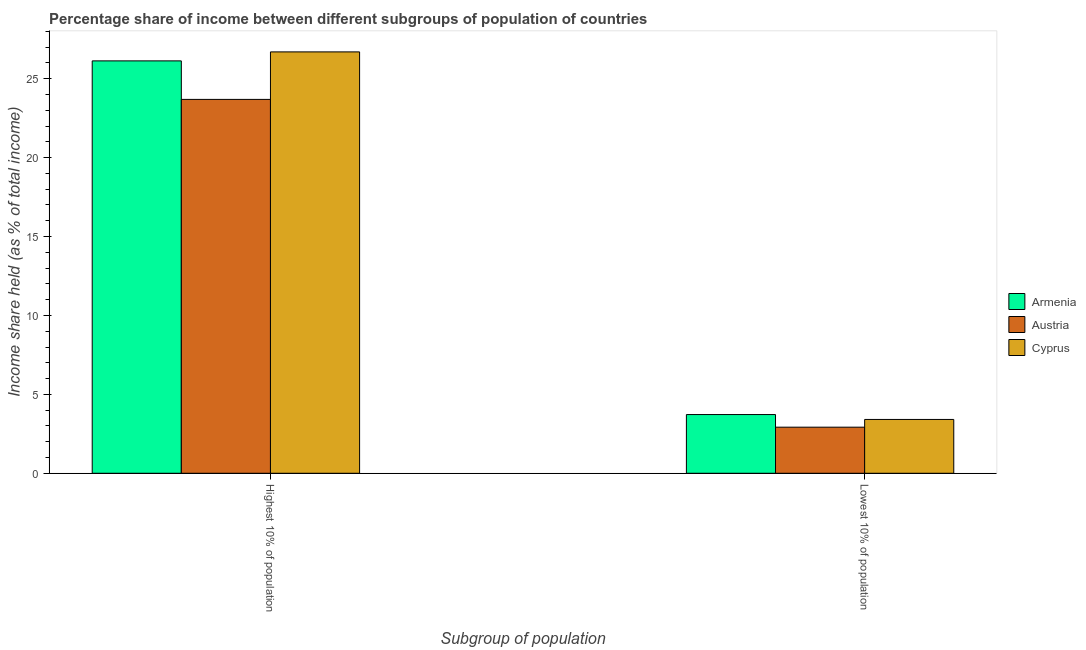How many different coloured bars are there?
Offer a terse response. 3. How many groups of bars are there?
Ensure brevity in your answer.  2. Are the number of bars on each tick of the X-axis equal?
Your response must be concise. Yes. How many bars are there on the 1st tick from the left?
Keep it short and to the point. 3. How many bars are there on the 2nd tick from the right?
Your answer should be very brief. 3. What is the label of the 1st group of bars from the left?
Provide a short and direct response. Highest 10% of population. What is the income share held by lowest 10% of the population in Cyprus?
Ensure brevity in your answer.  3.41. Across all countries, what is the maximum income share held by highest 10% of the population?
Your answer should be very brief. 26.7. Across all countries, what is the minimum income share held by highest 10% of the population?
Give a very brief answer. 23.69. In which country was the income share held by lowest 10% of the population maximum?
Offer a terse response. Armenia. What is the total income share held by highest 10% of the population in the graph?
Provide a short and direct response. 76.52. What is the difference between the income share held by lowest 10% of the population in Armenia and that in Cyprus?
Your answer should be compact. 0.31. What is the difference between the income share held by lowest 10% of the population in Cyprus and the income share held by highest 10% of the population in Austria?
Keep it short and to the point. -20.28. What is the average income share held by highest 10% of the population per country?
Provide a succinct answer. 25.51. What is the difference between the income share held by lowest 10% of the population and income share held by highest 10% of the population in Armenia?
Offer a very short reply. -22.41. What is the ratio of the income share held by highest 10% of the population in Cyprus to that in Austria?
Keep it short and to the point. 1.13. What does the 2nd bar from the right in Highest 10% of population represents?
Your answer should be very brief. Austria. Are all the bars in the graph horizontal?
Offer a very short reply. No. Are the values on the major ticks of Y-axis written in scientific E-notation?
Provide a succinct answer. No. Does the graph contain any zero values?
Provide a short and direct response. No. Does the graph contain grids?
Your answer should be very brief. No. How many legend labels are there?
Ensure brevity in your answer.  3. How are the legend labels stacked?
Offer a terse response. Vertical. What is the title of the graph?
Offer a terse response. Percentage share of income between different subgroups of population of countries. What is the label or title of the X-axis?
Ensure brevity in your answer.  Subgroup of population. What is the label or title of the Y-axis?
Your answer should be very brief. Income share held (as % of total income). What is the Income share held (as % of total income) in Armenia in Highest 10% of population?
Offer a very short reply. 26.13. What is the Income share held (as % of total income) of Austria in Highest 10% of population?
Your response must be concise. 23.69. What is the Income share held (as % of total income) in Cyprus in Highest 10% of population?
Keep it short and to the point. 26.7. What is the Income share held (as % of total income) in Armenia in Lowest 10% of population?
Offer a very short reply. 3.72. What is the Income share held (as % of total income) in Austria in Lowest 10% of population?
Offer a terse response. 2.92. What is the Income share held (as % of total income) in Cyprus in Lowest 10% of population?
Keep it short and to the point. 3.41. Across all Subgroup of population, what is the maximum Income share held (as % of total income) of Armenia?
Keep it short and to the point. 26.13. Across all Subgroup of population, what is the maximum Income share held (as % of total income) in Austria?
Your response must be concise. 23.69. Across all Subgroup of population, what is the maximum Income share held (as % of total income) of Cyprus?
Your answer should be very brief. 26.7. Across all Subgroup of population, what is the minimum Income share held (as % of total income) in Armenia?
Offer a terse response. 3.72. Across all Subgroup of population, what is the minimum Income share held (as % of total income) of Austria?
Your answer should be very brief. 2.92. Across all Subgroup of population, what is the minimum Income share held (as % of total income) of Cyprus?
Offer a very short reply. 3.41. What is the total Income share held (as % of total income) of Armenia in the graph?
Provide a succinct answer. 29.85. What is the total Income share held (as % of total income) in Austria in the graph?
Provide a short and direct response. 26.61. What is the total Income share held (as % of total income) of Cyprus in the graph?
Your answer should be very brief. 30.11. What is the difference between the Income share held (as % of total income) of Armenia in Highest 10% of population and that in Lowest 10% of population?
Keep it short and to the point. 22.41. What is the difference between the Income share held (as % of total income) of Austria in Highest 10% of population and that in Lowest 10% of population?
Provide a short and direct response. 20.77. What is the difference between the Income share held (as % of total income) of Cyprus in Highest 10% of population and that in Lowest 10% of population?
Ensure brevity in your answer.  23.29. What is the difference between the Income share held (as % of total income) in Armenia in Highest 10% of population and the Income share held (as % of total income) in Austria in Lowest 10% of population?
Make the answer very short. 23.21. What is the difference between the Income share held (as % of total income) of Armenia in Highest 10% of population and the Income share held (as % of total income) of Cyprus in Lowest 10% of population?
Your response must be concise. 22.72. What is the difference between the Income share held (as % of total income) of Austria in Highest 10% of population and the Income share held (as % of total income) of Cyprus in Lowest 10% of population?
Provide a short and direct response. 20.28. What is the average Income share held (as % of total income) in Armenia per Subgroup of population?
Offer a very short reply. 14.93. What is the average Income share held (as % of total income) in Austria per Subgroup of population?
Offer a very short reply. 13.3. What is the average Income share held (as % of total income) of Cyprus per Subgroup of population?
Offer a terse response. 15.05. What is the difference between the Income share held (as % of total income) in Armenia and Income share held (as % of total income) in Austria in Highest 10% of population?
Ensure brevity in your answer.  2.44. What is the difference between the Income share held (as % of total income) of Armenia and Income share held (as % of total income) of Cyprus in Highest 10% of population?
Your response must be concise. -0.57. What is the difference between the Income share held (as % of total income) of Austria and Income share held (as % of total income) of Cyprus in Highest 10% of population?
Your response must be concise. -3.01. What is the difference between the Income share held (as % of total income) in Armenia and Income share held (as % of total income) in Austria in Lowest 10% of population?
Make the answer very short. 0.8. What is the difference between the Income share held (as % of total income) in Armenia and Income share held (as % of total income) in Cyprus in Lowest 10% of population?
Make the answer very short. 0.31. What is the difference between the Income share held (as % of total income) of Austria and Income share held (as % of total income) of Cyprus in Lowest 10% of population?
Make the answer very short. -0.49. What is the ratio of the Income share held (as % of total income) of Armenia in Highest 10% of population to that in Lowest 10% of population?
Offer a terse response. 7.02. What is the ratio of the Income share held (as % of total income) of Austria in Highest 10% of population to that in Lowest 10% of population?
Your response must be concise. 8.11. What is the ratio of the Income share held (as % of total income) of Cyprus in Highest 10% of population to that in Lowest 10% of population?
Offer a very short reply. 7.83. What is the difference between the highest and the second highest Income share held (as % of total income) in Armenia?
Your response must be concise. 22.41. What is the difference between the highest and the second highest Income share held (as % of total income) in Austria?
Offer a terse response. 20.77. What is the difference between the highest and the second highest Income share held (as % of total income) of Cyprus?
Your response must be concise. 23.29. What is the difference between the highest and the lowest Income share held (as % of total income) of Armenia?
Offer a very short reply. 22.41. What is the difference between the highest and the lowest Income share held (as % of total income) in Austria?
Make the answer very short. 20.77. What is the difference between the highest and the lowest Income share held (as % of total income) of Cyprus?
Offer a terse response. 23.29. 